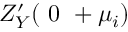Convert formula to latex. <formula><loc_0><loc_0><loc_500><loc_500>Z _ { Y } ^ { \prime } ( { 0 + \mu _ { i } } )</formula> 